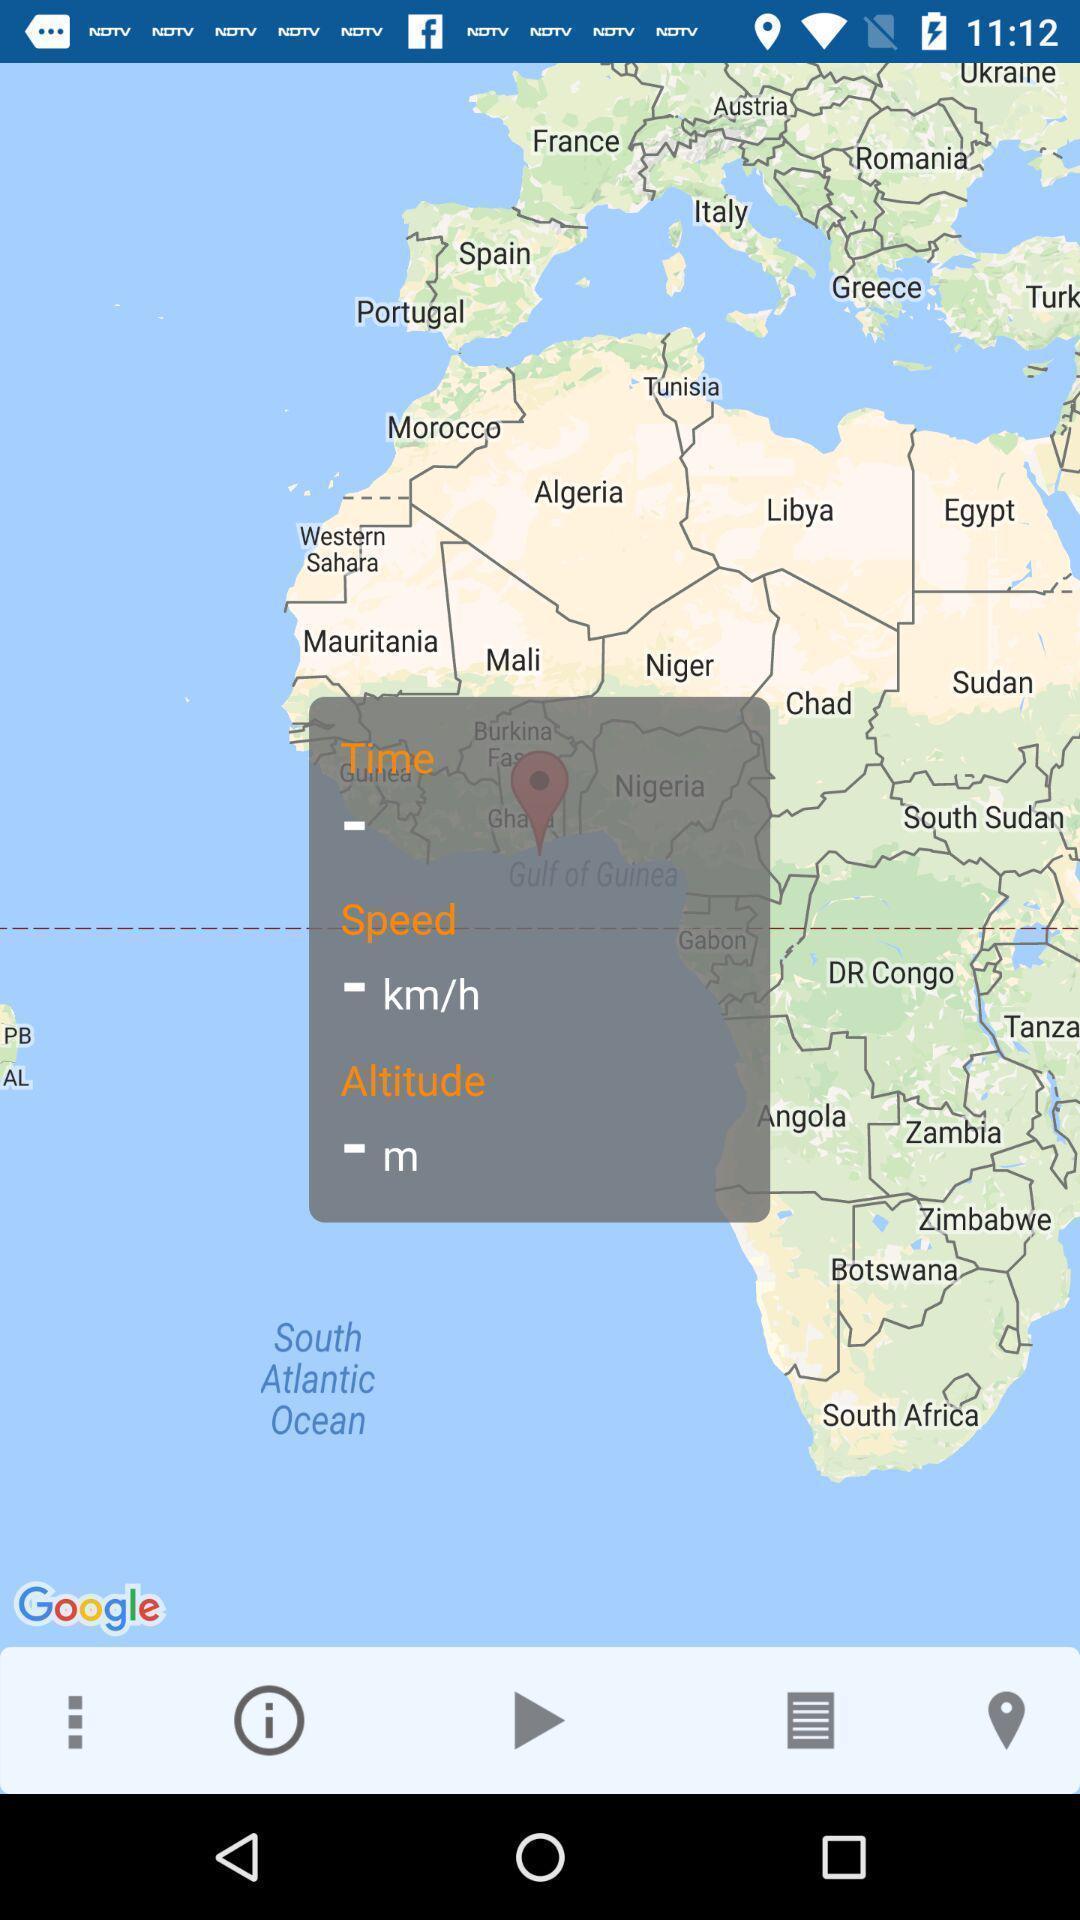Give me a narrative description of this picture. Screen shows map view in a navigation app. 